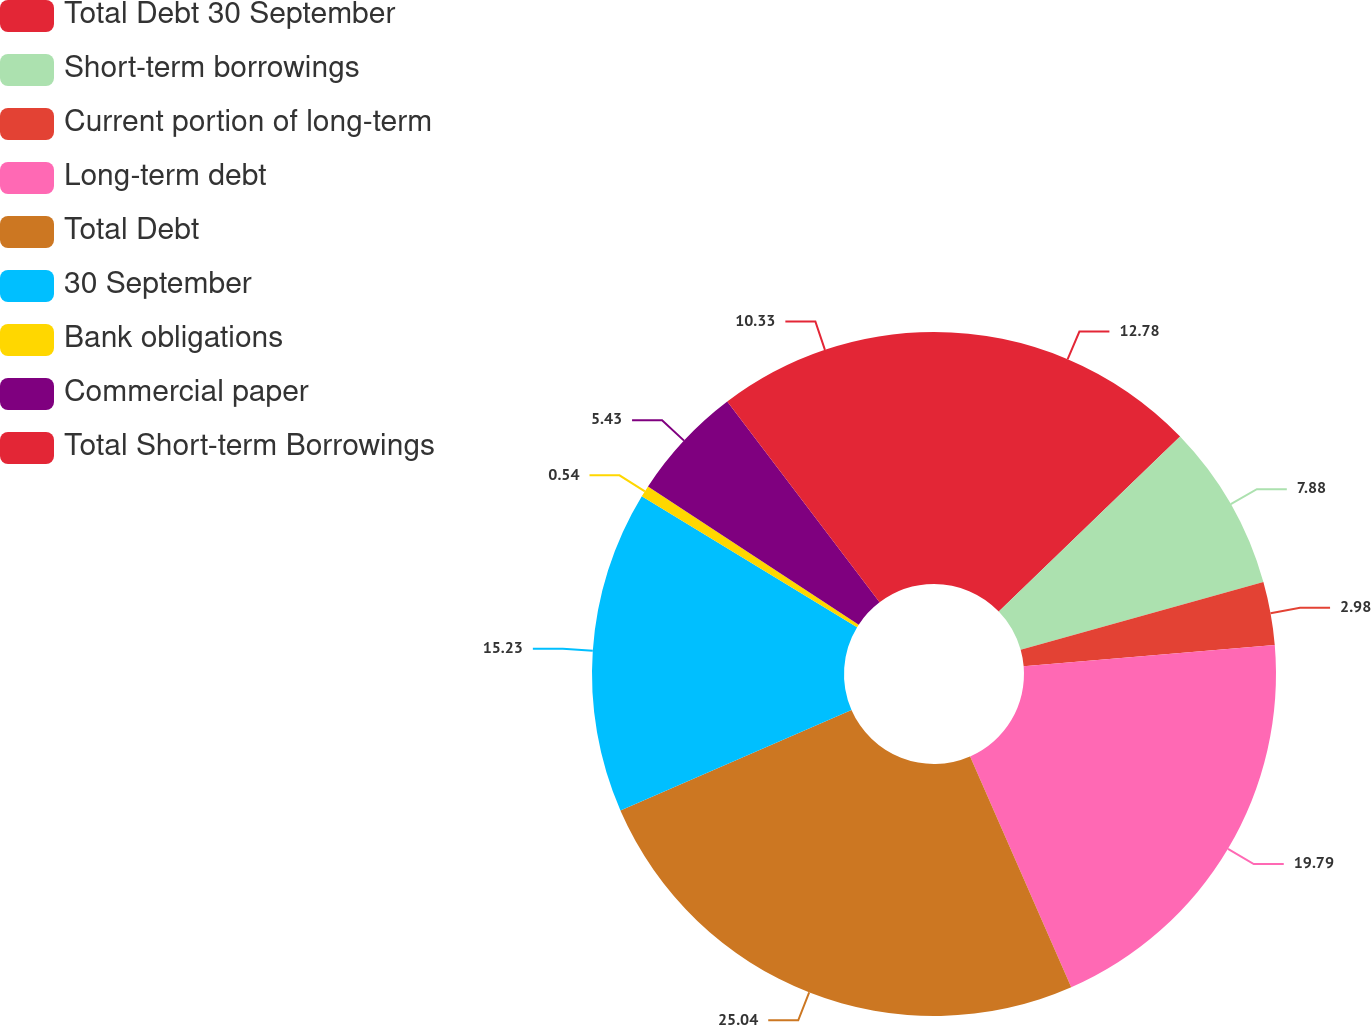Convert chart. <chart><loc_0><loc_0><loc_500><loc_500><pie_chart><fcel>Total Debt 30 September<fcel>Short-term borrowings<fcel>Current portion of long-term<fcel>Long-term debt<fcel>Total Debt<fcel>30 September<fcel>Bank obligations<fcel>Commercial paper<fcel>Total Short-term Borrowings<nl><fcel>12.78%<fcel>7.88%<fcel>2.98%<fcel>19.78%<fcel>25.03%<fcel>15.23%<fcel>0.54%<fcel>5.43%<fcel>10.33%<nl></chart> 